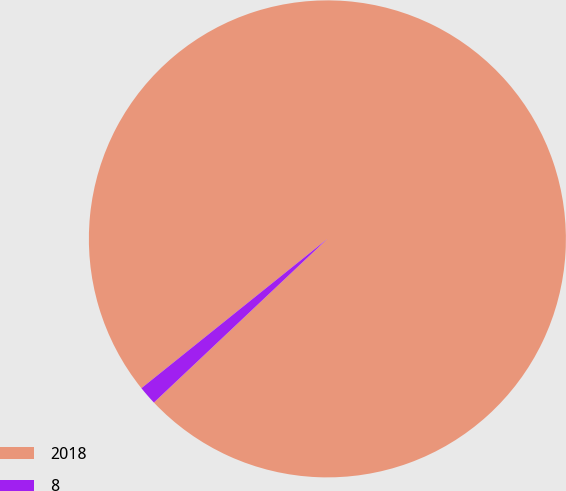Convert chart to OTSL. <chart><loc_0><loc_0><loc_500><loc_500><pie_chart><fcel>2018<fcel>8<nl><fcel>98.73%<fcel>1.27%<nl></chart> 